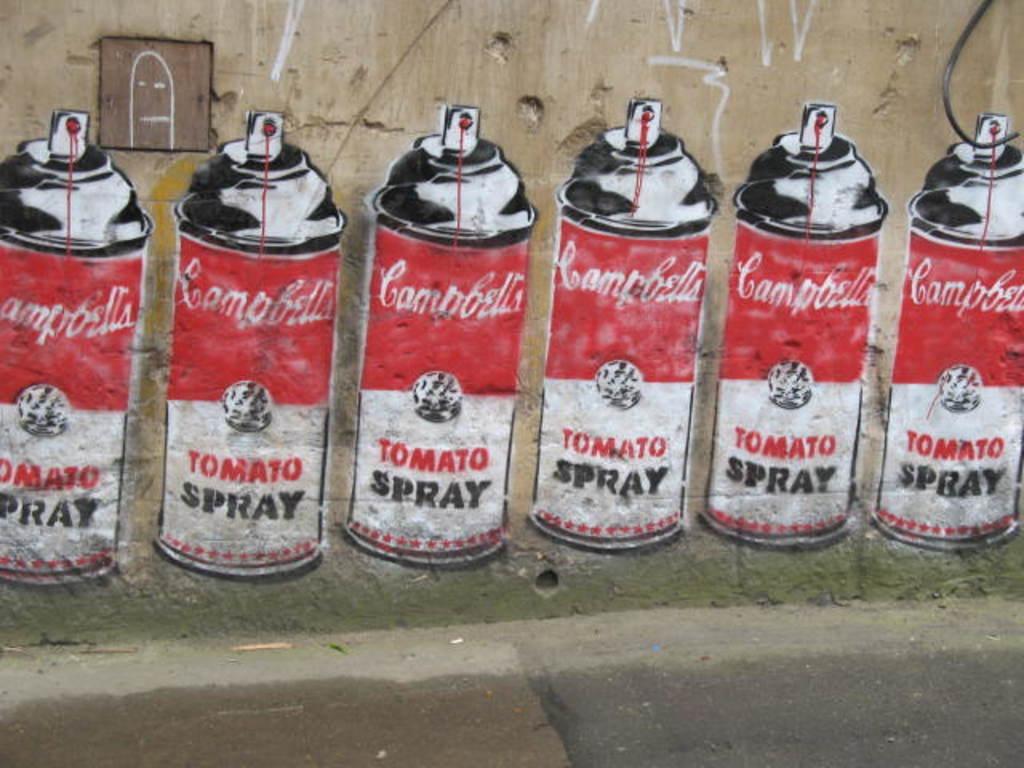What type of product is painted on the wall?
Offer a very short reply. Tomato spray. What does the left can say?
Offer a very short reply. Tomato spray. 